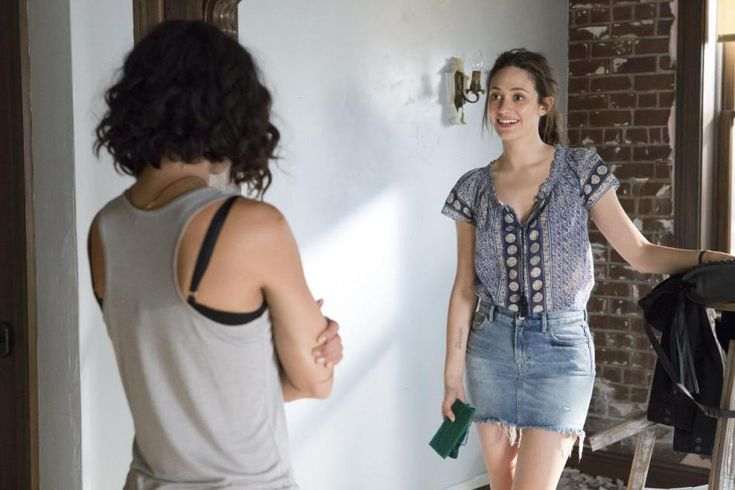What genre of music might suit the atmosphere of this image and why? A soft indie or acoustic genre would suit the atmosphere of this image perfectly. The relaxed and intimate setting, combined with the warm and friendly interaction between the two women, calls for music that is soothing and unobtrusive. Artists like Iron & Wine, Bon Iver, or The Lumineers could provide a perfect soundtrack to this scene, enhancing the cozy and heartfelt ambiance with their gentle melodies and meaningful lyrics. 